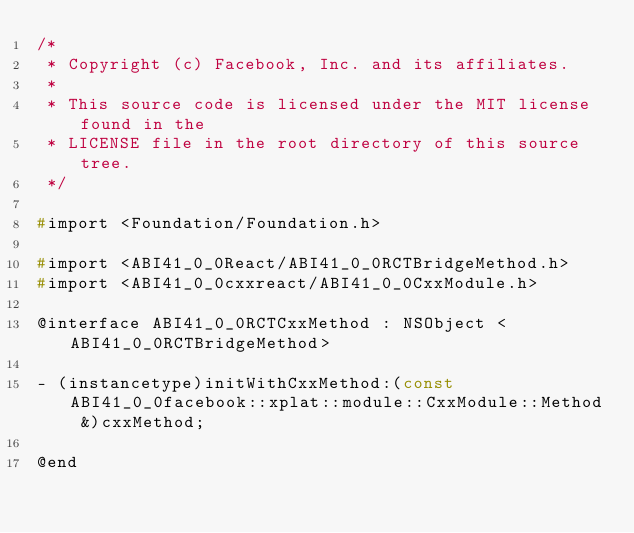Convert code to text. <code><loc_0><loc_0><loc_500><loc_500><_C_>/*
 * Copyright (c) Facebook, Inc. and its affiliates.
 *
 * This source code is licensed under the MIT license found in the
 * LICENSE file in the root directory of this source tree.
 */

#import <Foundation/Foundation.h>

#import <ABI41_0_0React/ABI41_0_0RCTBridgeMethod.h>
#import <ABI41_0_0cxxreact/ABI41_0_0CxxModule.h>

@interface ABI41_0_0RCTCxxMethod : NSObject <ABI41_0_0RCTBridgeMethod>

- (instancetype)initWithCxxMethod:(const ABI41_0_0facebook::xplat::module::CxxModule::Method &)cxxMethod;

@end
</code> 